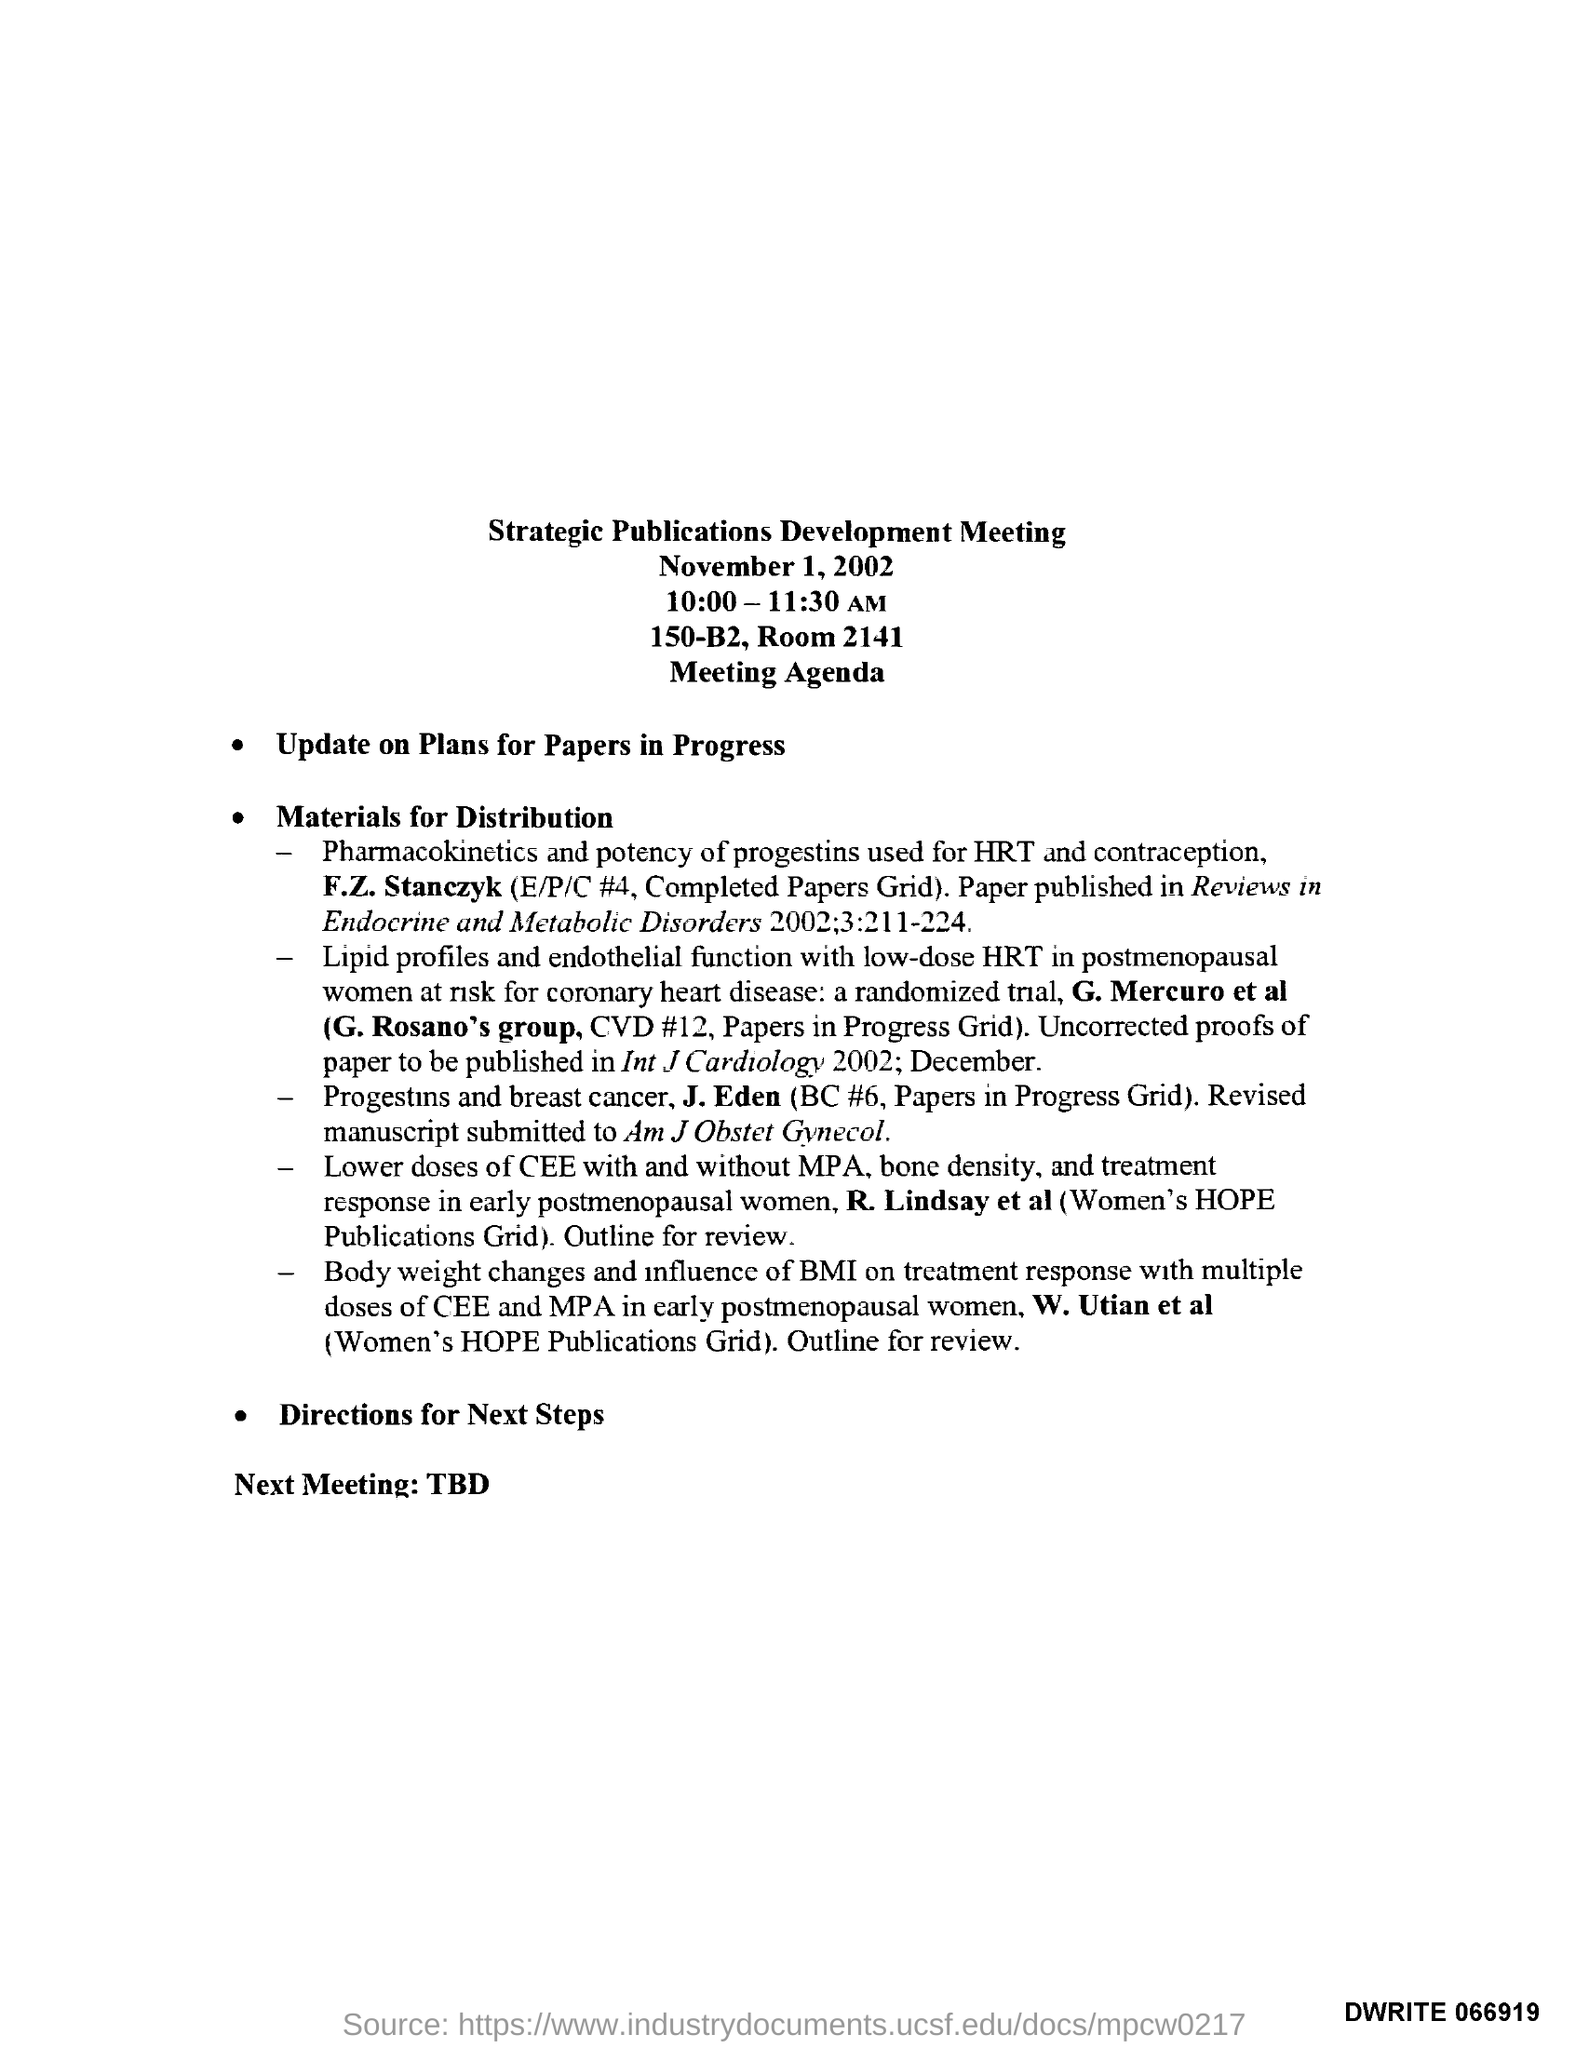Give some essential details in this illustration. The document's title is "Strategic Publications Development Meeting. The meeting is scheduled to take place between 10:00 and 11:30 AM. 